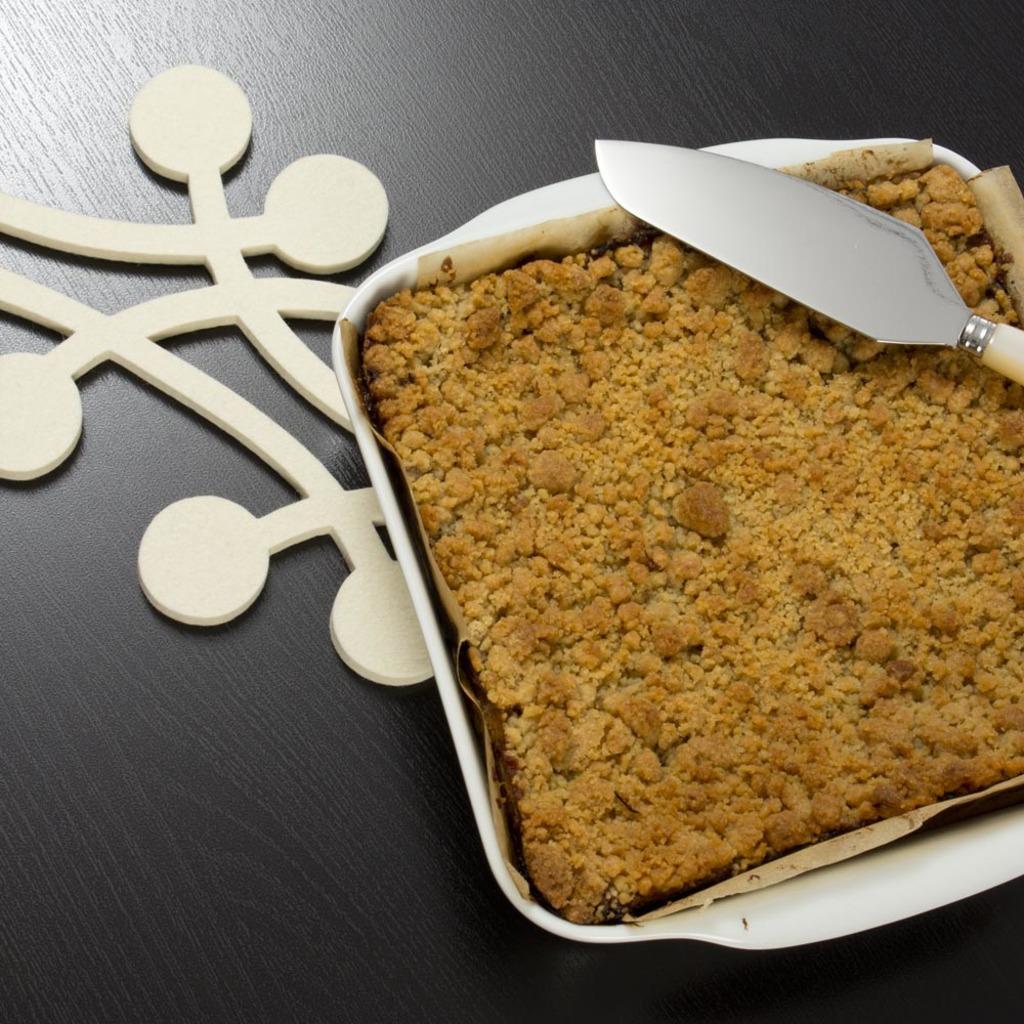In one or two sentences, can you explain what this image depicts? On this wooden surface we can see a bowl with food and knife. 